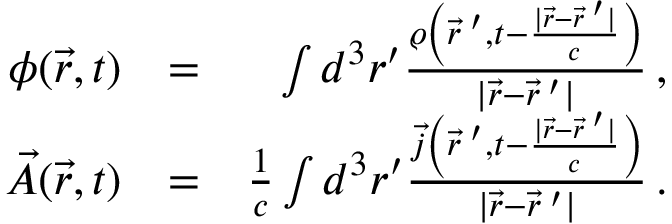Convert formula to latex. <formula><loc_0><loc_0><loc_500><loc_500>\begin{array} { r l r } { \phi ( \vec { r } , t ) } & { = } & { \int d ^ { 3 } r ^ { \prime } \frac { \varrho \left ( \vec { r } \, ^ { \prime } , t - \frac { | \vec { r } - \vec { r } \, ^ { \prime } | } { c } \right ) } { | \vec { r } - \vec { r } \, ^ { \prime } | } \, , } \\ { \vec { A } ( \vec { r } , t ) } & { = } & { \frac { 1 } { c } \int d ^ { 3 } r ^ { \prime } \frac { \vec { j } \left ( \vec { r } \, ^ { \prime } , t - \frac { | \vec { r } - \vec { r } \, ^ { \prime } | } { c } \right ) } { | \vec { r } - \vec { r } \, ^ { \prime } | } \, . } \end{array}</formula> 